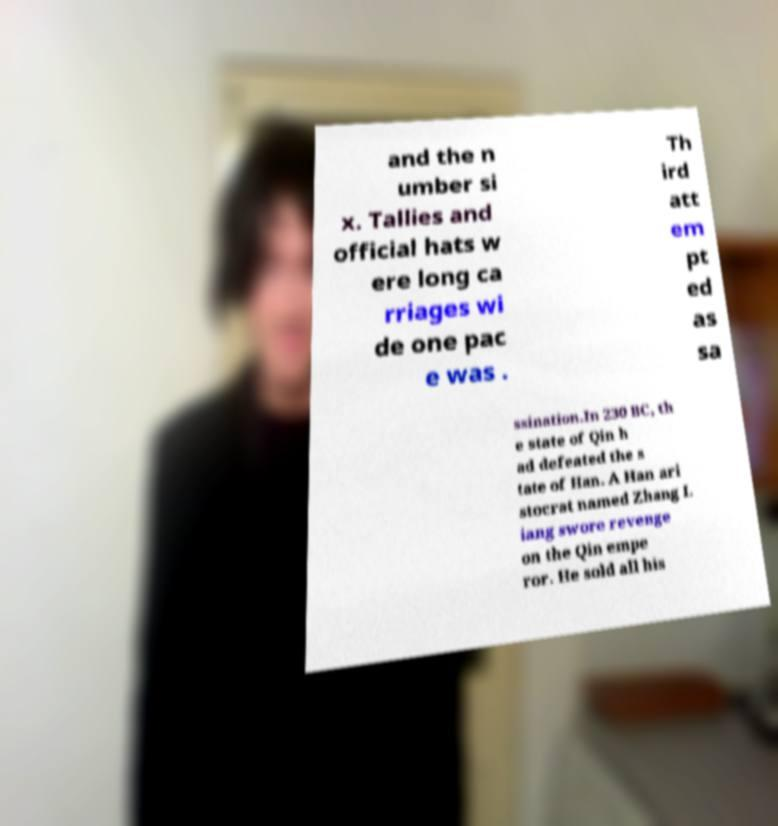I need the written content from this picture converted into text. Can you do that? and the n umber si x. Tallies and official hats w ere long ca rriages wi de one pac e was . Th ird att em pt ed as sa ssination.In 230 BC, th e state of Qin h ad defeated the s tate of Han. A Han ari stocrat named Zhang L iang swore revenge on the Qin empe ror. He sold all his 